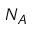<formula> <loc_0><loc_0><loc_500><loc_500>N _ { A }</formula> 